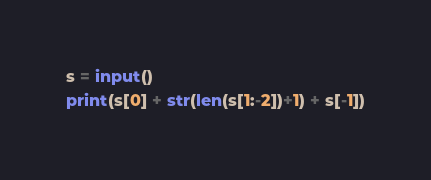<code> <loc_0><loc_0><loc_500><loc_500><_Python_>s = input()
print(s[0] + str(len(s[1:-2])+1) + s[-1])</code> 